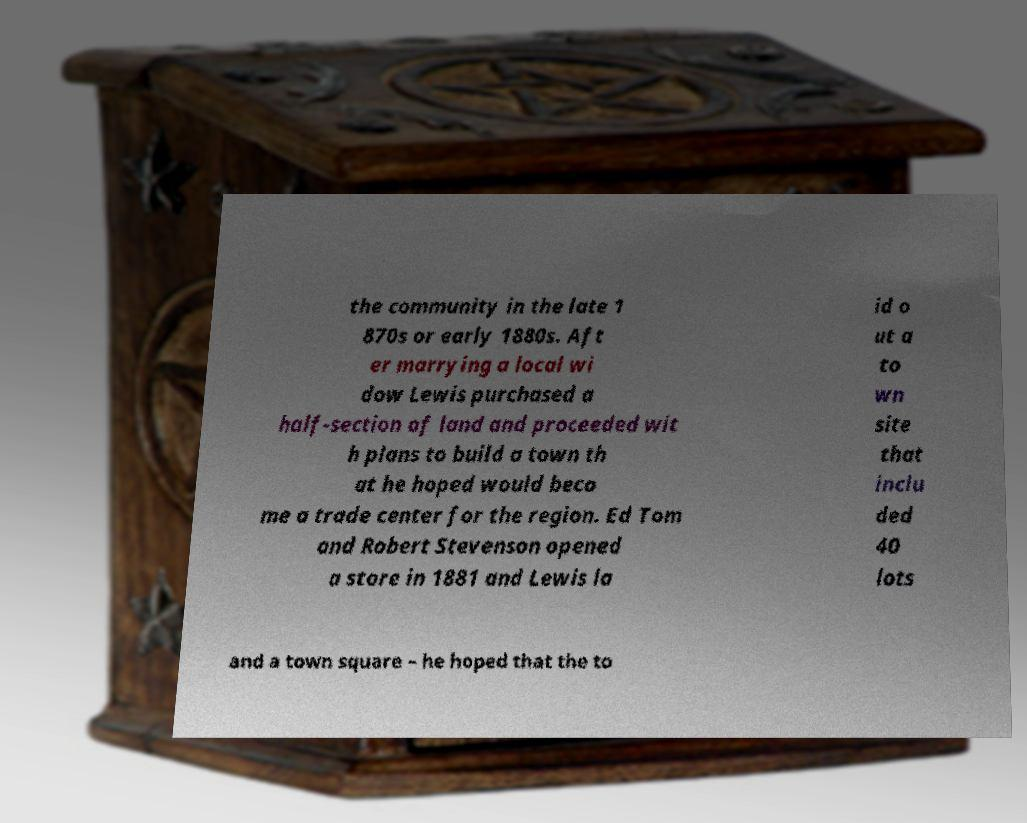Please read and relay the text visible in this image. What does it say? the community in the late 1 870s or early 1880s. Aft er marrying a local wi dow Lewis purchased a half-section of land and proceeded wit h plans to build a town th at he hoped would beco me a trade center for the region. Ed Tom and Robert Stevenson opened a store in 1881 and Lewis la id o ut a to wn site that inclu ded 40 lots and a town square – he hoped that the to 